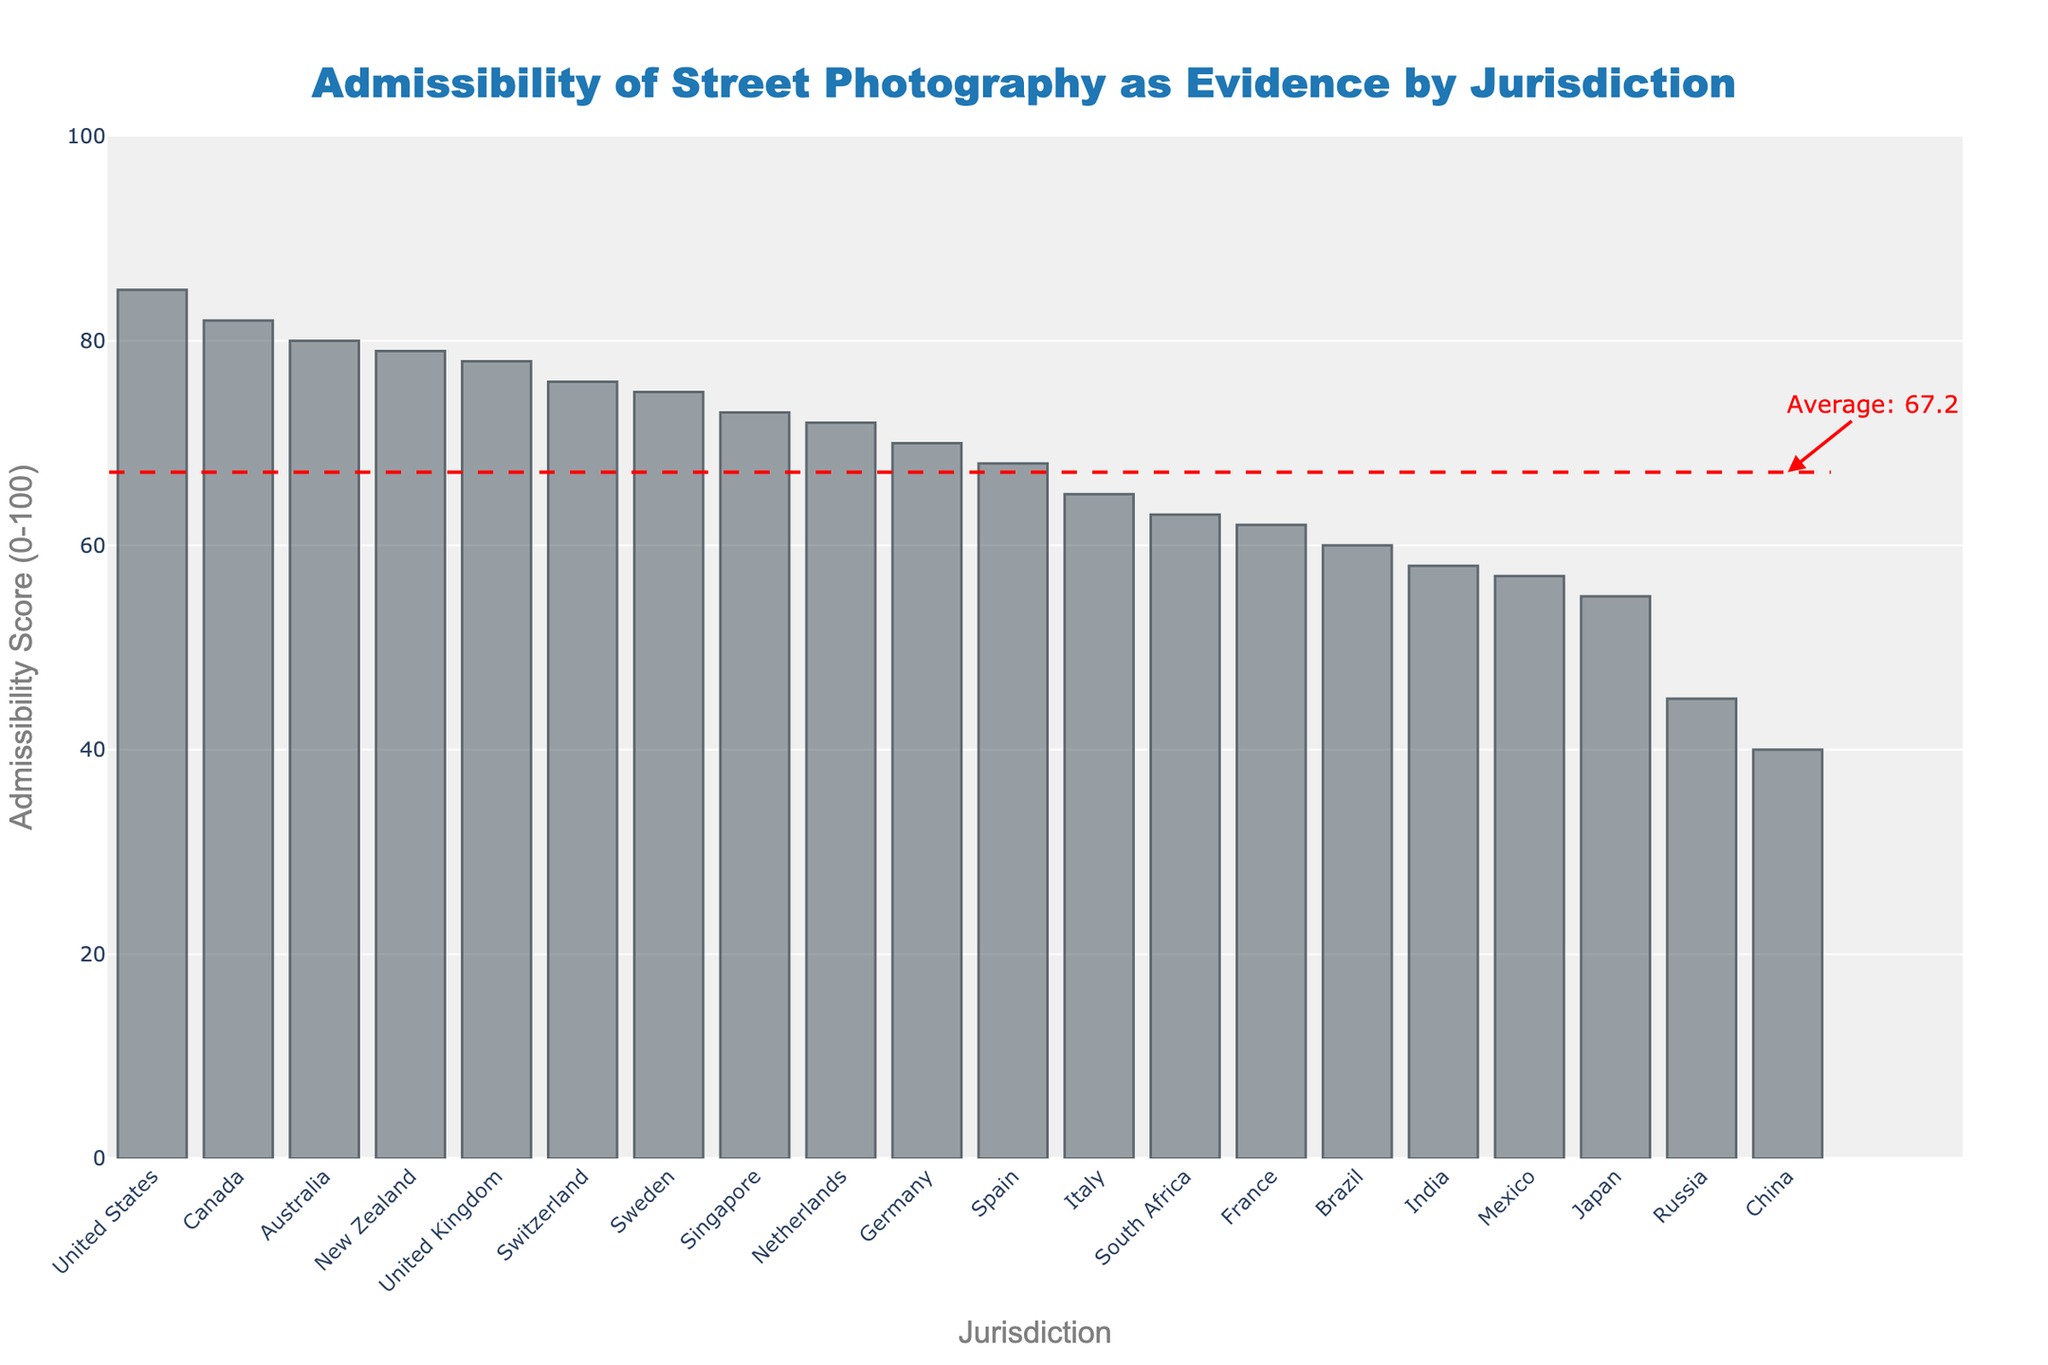Which jurisdiction has the highest admissibility score? The bar with the highest height represents the highest admissibility score. By observing the chart, the United States stands out.
Answer: United States How does the admissibility score of Germany compare to that of the United Kingdom? By examining the figure, we see the bars for both Germany and the United Kingdom. The height of the bar for the United Kingdom is higher than that of Germany.
Answer: The United Kingdom has a higher score than Germany Which jurisdictions have an admissibility score below the average line? The average line is drawn in red. Jurisdictions with bars not reaching this line are Brazil, India, South Africa, Mexico, Russia, and China.
Answer: Brazil, India, South Africa, Mexico, Russia, China What is the difference in admissibility scores between the highest and lowest jurisdictions? The highest score is the United States with 85 and the lowest is China with 40. The difference is calculated as 85 - 40.
Answer: 45 Which jurisdiction falls just above the average admissibility score? Looking closely at the bar chart, Switzerland has a score slightly above the average line.
Answer: Switzerland What is the median admissibility score among the jurisdictions? To find the median, we list all the scores and locate the middle value. The list ordered is [40, 45, 55, 57, 58, 60, 62, 63, 65, 68, 70, 72, 73, 75, 76, 78, 79, 80, 82, 85]. The middle values are 68 (Spain) and 70 (Germany), and the median is the average of these.
Answer: 69 What visual indicator depicts the average admissibility score in the chart? The red dashed horizontal line marks the position of the average admissibility score, as indicated by the annotation at its end.
Answer: Red dashed line How many jurisdictions have an admissibility score of 70 or above? By counting the bars that reach or surpass the score of 70, we find the following jurisdictions: United States, United Kingdom, Germany, Australia, Canada, Netherlands, Sweden, New Zealand, Singapore, Switzerland.
Answer: 10 Which jurisdiction shows the closest admissibility score to France? Observing the heights of the bars, Germany's score is nearest to France's score of 62. Germany has a score of 70.
Answer: Germany What is the total sum of the admissibility scores for France and Italy? France has a score of 62 and Italy a score of 65. Adding these together gives a total of 62 + 65.
Answer: 127 